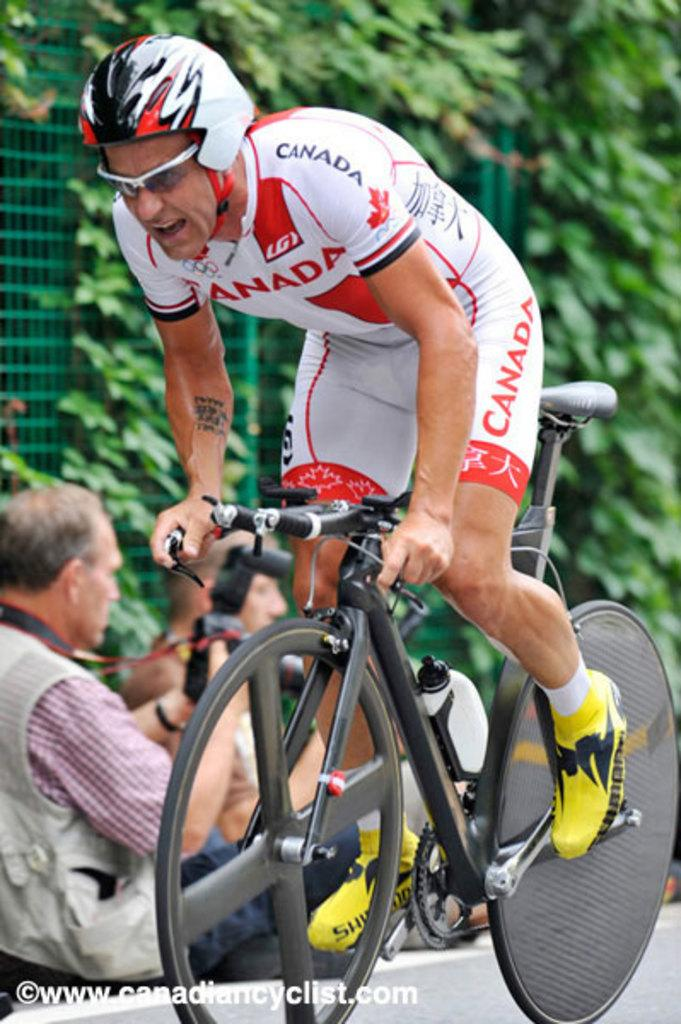What is the main activity of the person in the image? There is a person riding a bicycle in the image. What is the other person in the image doing? There is a person sitting on the road in the image. What can be seen in the background of the image? There is a creep visible in the image. What type of seat is the corn sitting on in the image? There is no corn present in the image, so it cannot be sitting on any seat. 